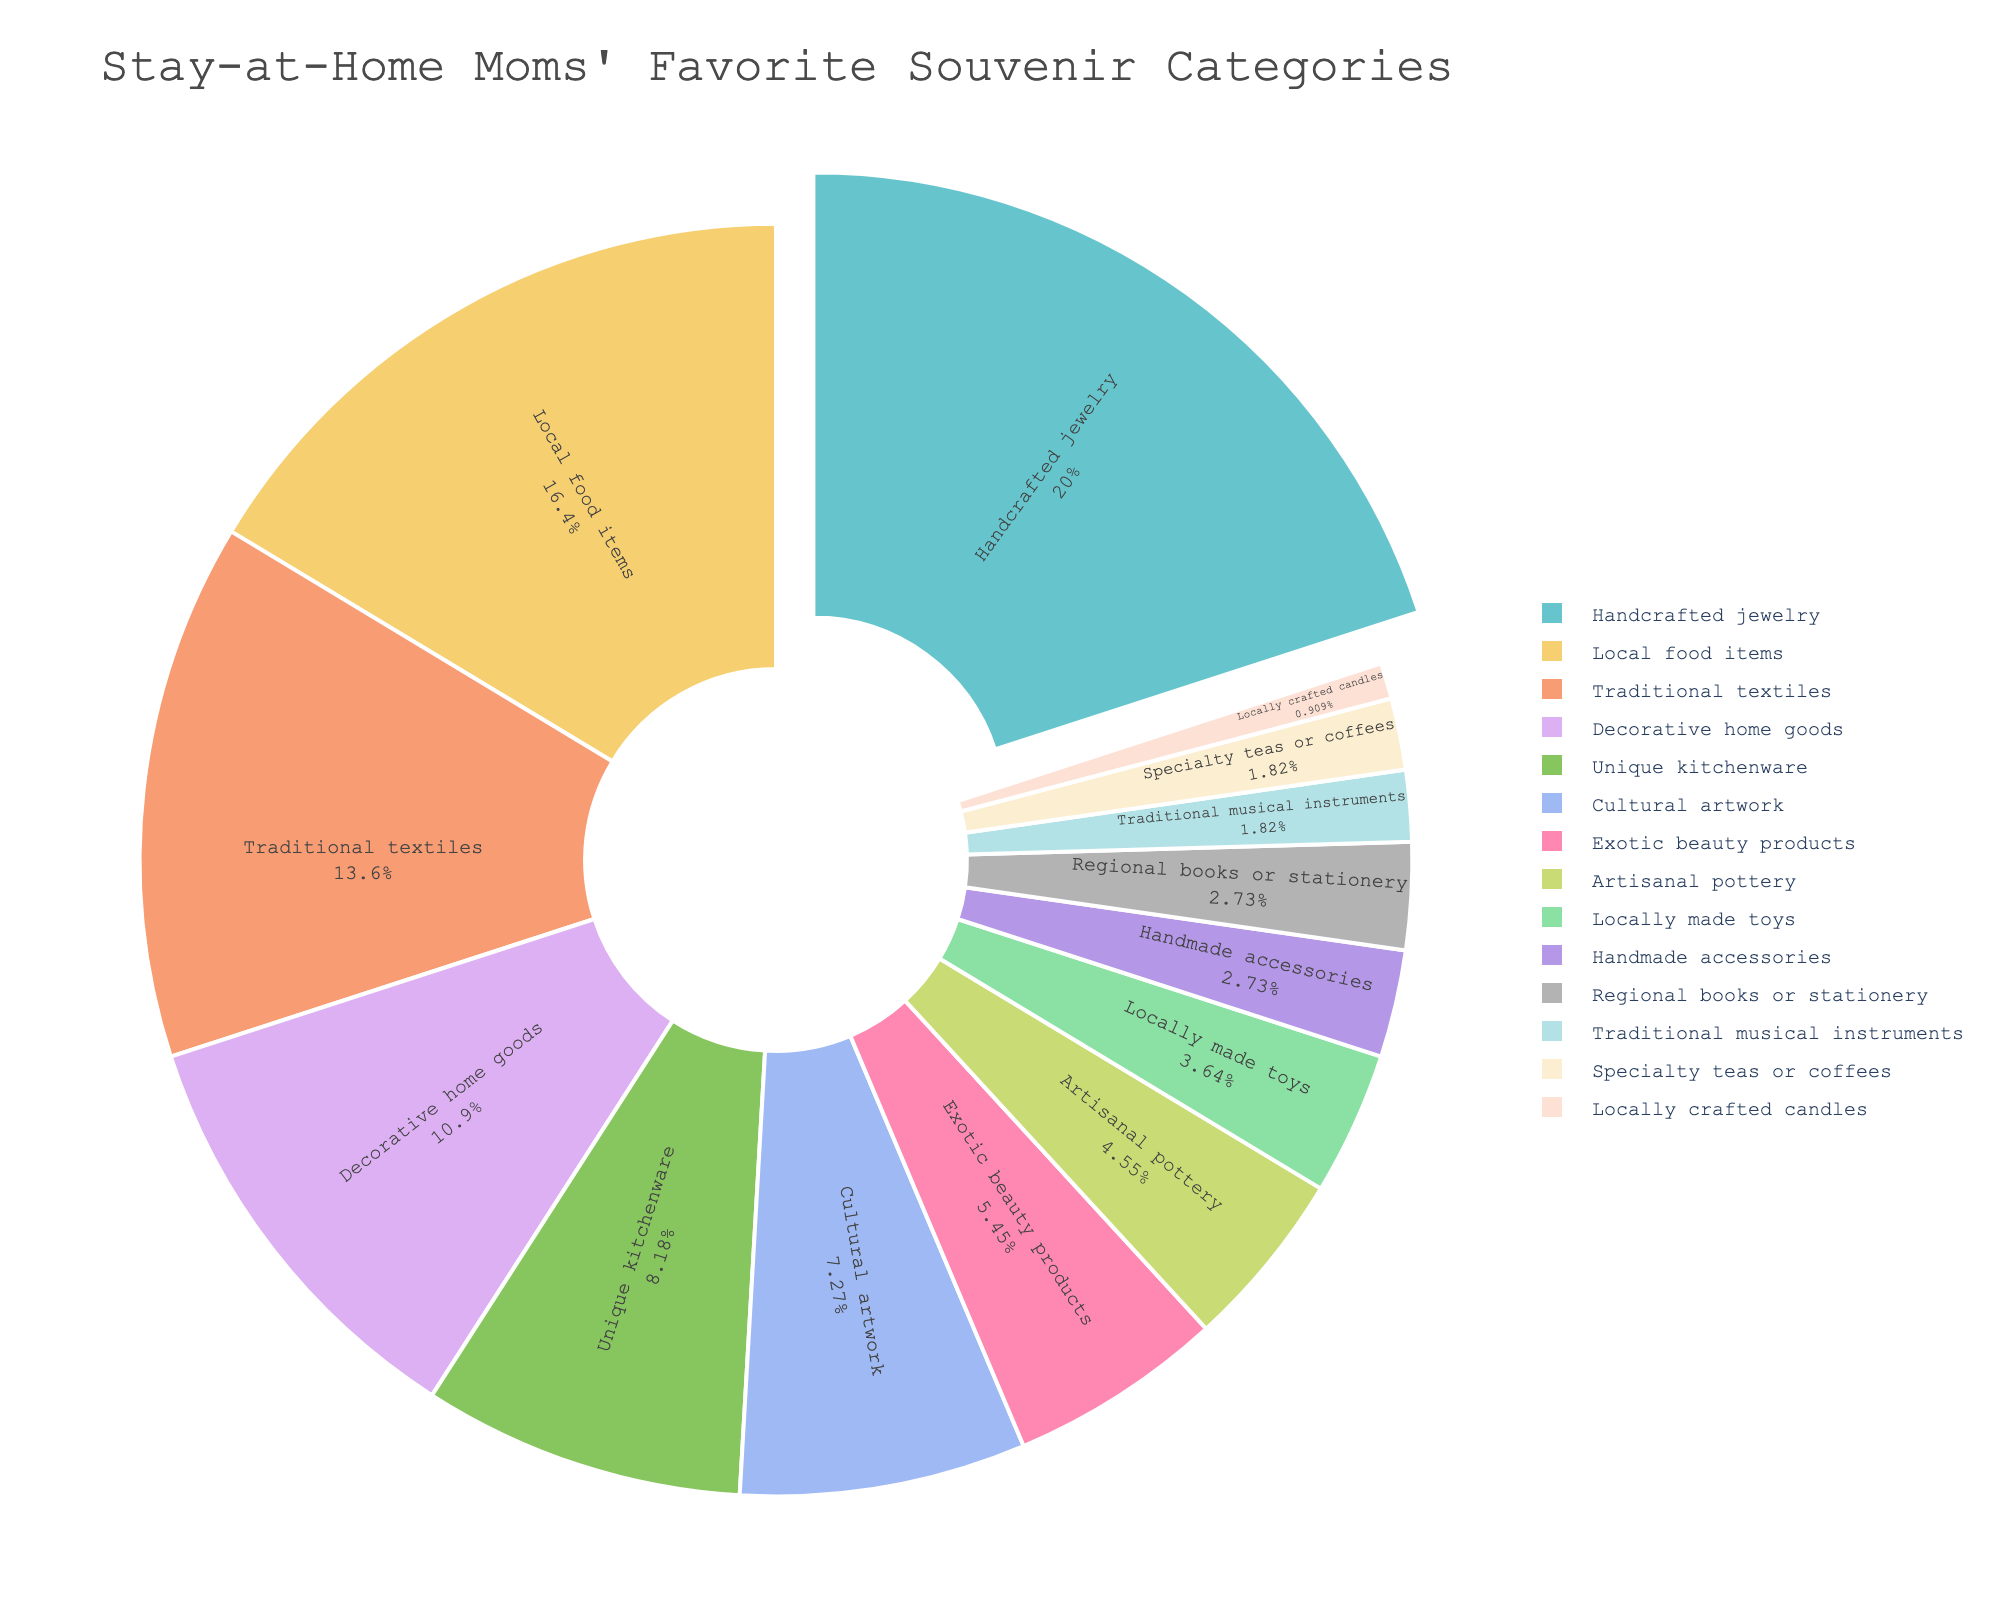What is the most popular souvenir category among stay-at-home moms? The pie chart shows that "Handcrafted jewelry" has the highest percentage, which means it is the most popular category.
Answer: Handcrafted jewelry Which categories have a percentage greater than 15%? The pie chart shows "Handcrafted jewelry" at 22%, "Local food items" at 18%, and "Traditional textiles" at 15%. Therefore, the categories with more than 15% are "Handcrafted jewelry" and "Local food items."
Answer: Handcrafted jewelry, Local food items By how much does the category with the highest percentage exceed the category with the lowest percentage? "Handcrafted jewelry" has the highest percentage at 22%, and "Locally crafted candles" has the lowest percentage at 1%. Subtracting these, 22 - 1 = 21%.
Answer: 21% Which souvenir category is represented by the green color segment in the pie? Visually, in many pie charts, green is commonly used in qualitative color sequences for local food items. According to the data and typical color assignments, the green segment corresponds to "Local food items."
Answer: Local food items What is the combined percentage of "Decorative home goods," "Unique kitchenware," and "Cultural artwork"? According to the pie chart, the percentages are: "Decorative home goods" 12%, "Unique kitchenware" 9%, "Cultural artwork" 8%. The sum is 12 + 9 + 8 = 29%.
Answer: 29% Which souvenir categories fall between 5% to 10%? The pie chart shows that "Unique kitchenware" has 9%, "Cultural artwork" has 8%, and "Exotic beauty products" has 6%. Only these categories fall within the 5% to 10% range.
Answer: Unique kitchenware, Cultural artwork, Exotic beauty products How many categories have a percentage less than 5%? According to the pie chart, "Artisanal pottery" (5%), "Locally made toys" (4%), "Handmade accessories" (3%), "Regional books or stationery" (3%), "Traditional musical instruments" (2%), "Specialty teas or coffees" (2%), and "Locally crafted candles" (1%) are below 5%. There are 7 such categories.
Answer: 7 Is the percentage of "Traditional textiles" greater or less than the sum of "Locally made toys" and "Traditional musical instruments"? "Traditional textiles" has 15%. "Locally made toys" and "Traditional musical instruments" have 4% and 2%, respectively. The sum is 4 + 2 = 6%, which is less than 15%.
Answer: Greater 